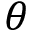<formula> <loc_0><loc_0><loc_500><loc_500>\theta</formula> 